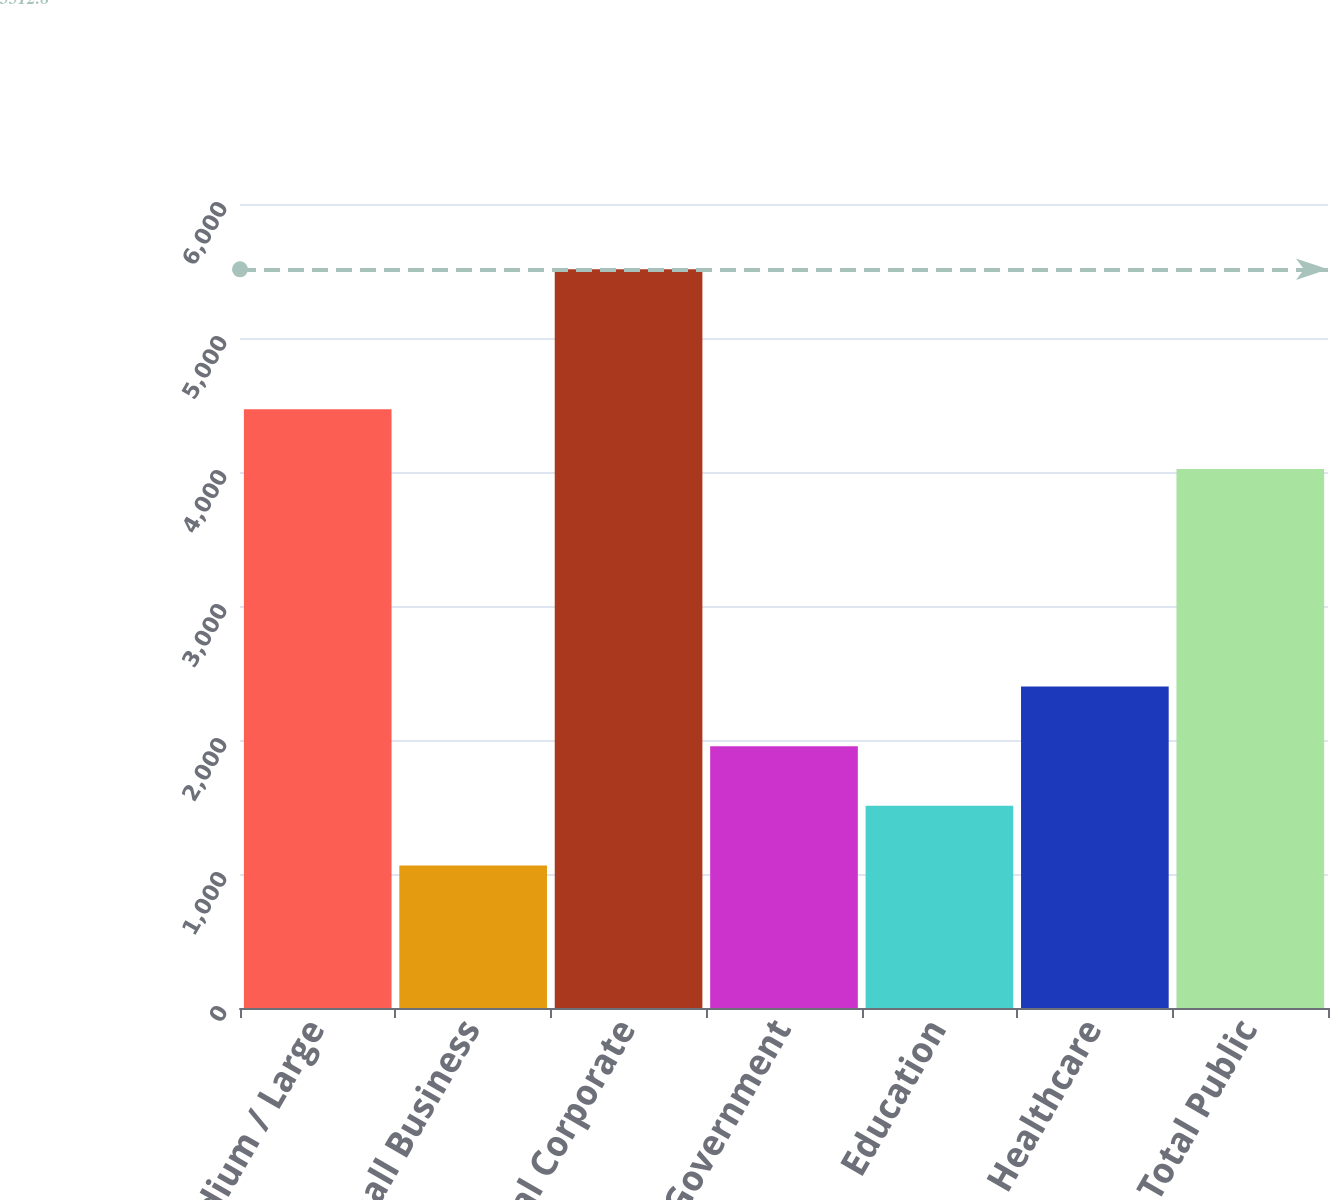<chart> <loc_0><loc_0><loc_500><loc_500><bar_chart><fcel>Medium / Large<fcel>Small Business<fcel>Total Corporate<fcel>Government<fcel>Education<fcel>Healthcare<fcel>Total Public<nl><fcel>4467.85<fcel>1064.3<fcel>5512.8<fcel>1954<fcel>1509.15<fcel>2398.85<fcel>4023<nl></chart> 